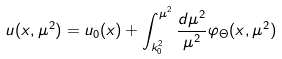Convert formula to latex. <formula><loc_0><loc_0><loc_500><loc_500>u ( x , \mu ^ { 2 } ) = u _ { 0 } ( x ) + \int _ { k _ { 0 } ^ { 2 } } ^ { \mu ^ { 2 } } \frac { d \mu ^ { 2 } } { \mu ^ { 2 } } \varphi _ { \Theta } ( x , \mu ^ { 2 } )</formula> 